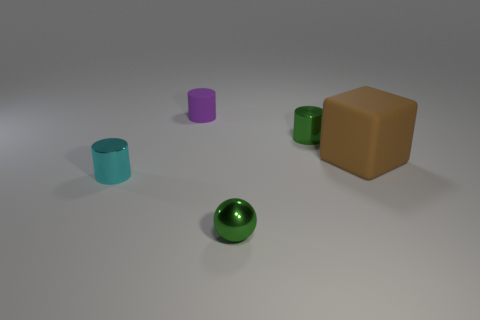Add 1 yellow metal cylinders. How many objects exist? 6 Subtract all balls. How many objects are left? 4 Add 3 green shiny objects. How many green shiny objects exist? 5 Subtract 0 purple balls. How many objects are left? 5 Subtract all tiny cyan rubber cylinders. Subtract all large rubber blocks. How many objects are left? 4 Add 5 cyan cylinders. How many cyan cylinders are left? 6 